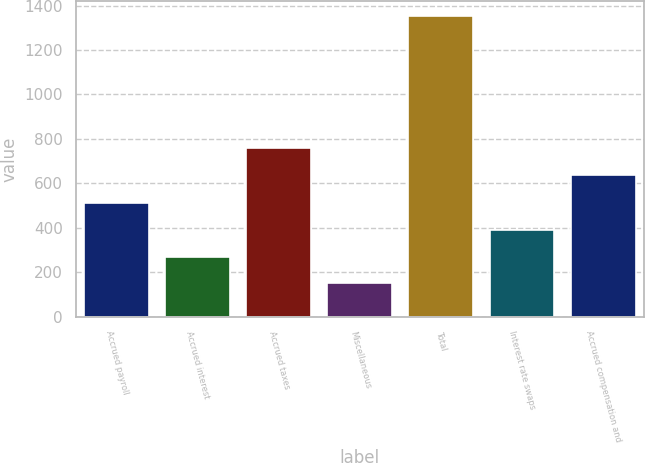Convert chart. <chart><loc_0><loc_0><loc_500><loc_500><bar_chart><fcel>Accrued payroll<fcel>Accrued interest<fcel>Accrued taxes<fcel>Miscellaneous<fcel>Total<fcel>Interest rate swaps<fcel>Accrued compensation and<nl><fcel>510.9<fcel>270.3<fcel>758.3<fcel>150<fcel>1353<fcel>390.6<fcel>638<nl></chart> 